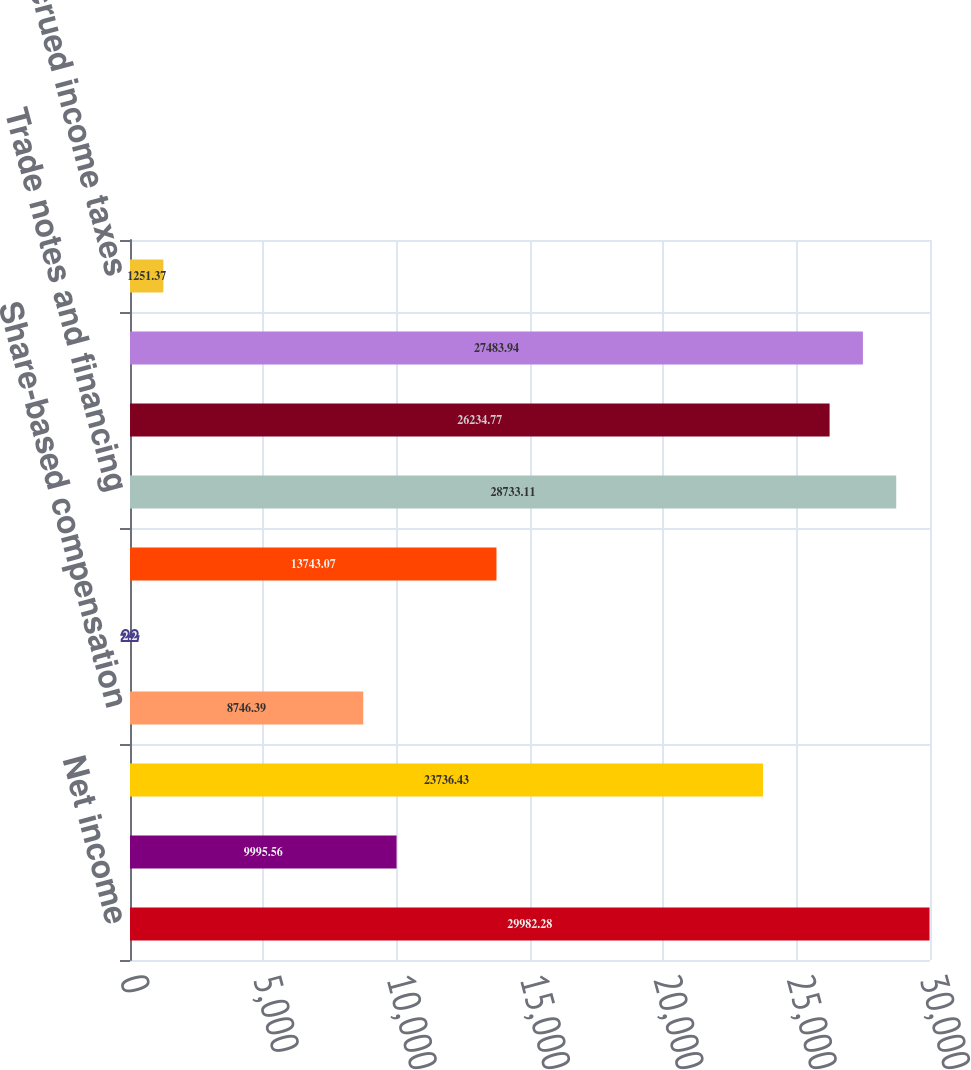Convert chart to OTSL. <chart><loc_0><loc_0><loc_500><loc_500><bar_chart><fcel>Net income<fcel>Provision for doubtful<fcel>Provision for depreciation and<fcel>Share-based compensation<fcel>Undistributed earnings of<fcel>Provision (credit) for<fcel>Trade notes and financing<fcel>Inventories<fcel>Accounts payable and accrued<fcel>Accrued income taxes<nl><fcel>29982.3<fcel>9995.56<fcel>23736.4<fcel>8746.39<fcel>2.2<fcel>13743.1<fcel>28733.1<fcel>26234.8<fcel>27483.9<fcel>1251.37<nl></chart> 